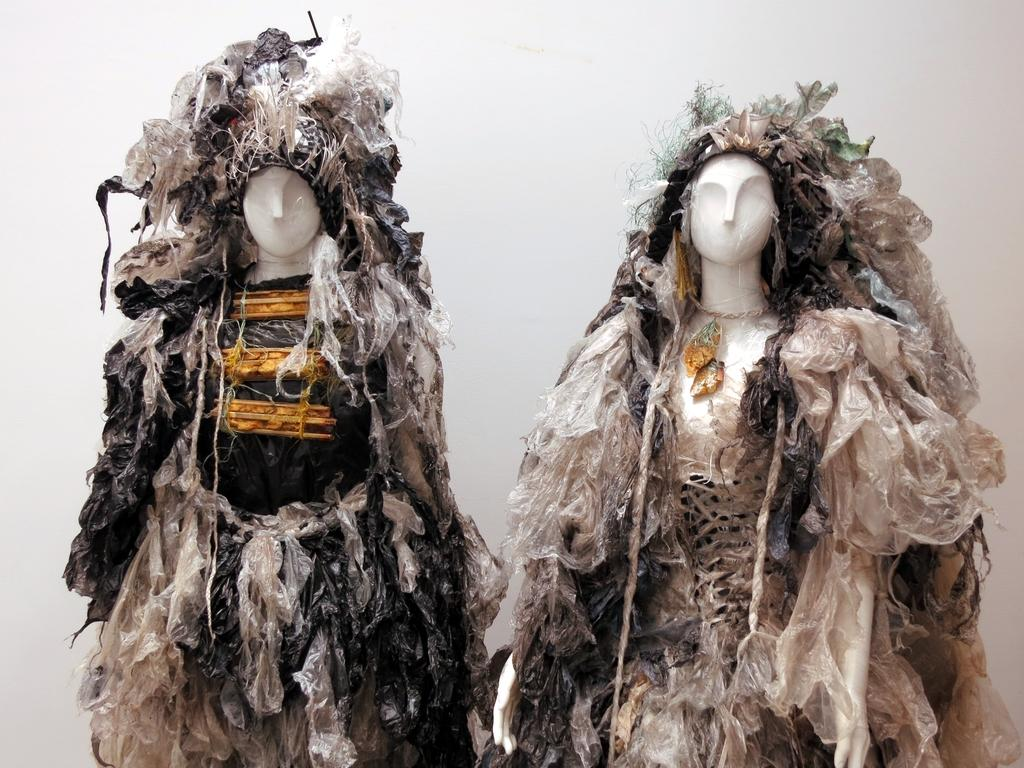How many mannequins are present in the image? There are two mannequins in the image. What are the mannequins wearing? The mannequins are wearing clothes. What is the color of the background in the image? The background of the image is white in color. Reasoning: Let's think step by step by step in order to produce the conversation. We start by identifying the main subjects in the image, which are the two mannequins. Then, we describe what the mannequins are doing or wearing, which in this case is that they are wearing clothes. Finally, we mention the background color to give a sense of the overall setting. Absurd Question/Answer: Can you tell me how many brains are visible in the image? There are no brains visible in the image; it features two mannequins wearing clothes against a white background. What type of alley can be seen in the image? There is no alley present in the image. 